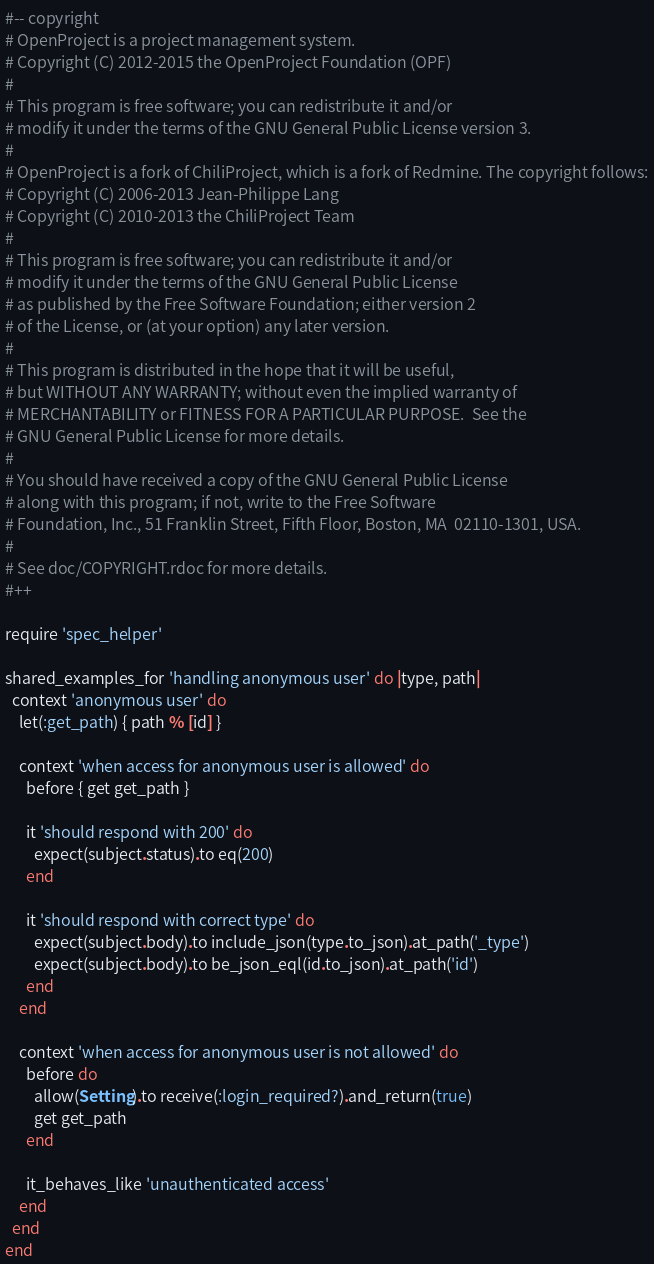<code> <loc_0><loc_0><loc_500><loc_500><_Ruby_>#-- copyright
# OpenProject is a project management system.
# Copyright (C) 2012-2015 the OpenProject Foundation (OPF)
#
# This program is free software; you can redistribute it and/or
# modify it under the terms of the GNU General Public License version 3.
#
# OpenProject is a fork of ChiliProject, which is a fork of Redmine. The copyright follows:
# Copyright (C) 2006-2013 Jean-Philippe Lang
# Copyright (C) 2010-2013 the ChiliProject Team
#
# This program is free software; you can redistribute it and/or
# modify it under the terms of the GNU General Public License
# as published by the Free Software Foundation; either version 2
# of the License, or (at your option) any later version.
#
# This program is distributed in the hope that it will be useful,
# but WITHOUT ANY WARRANTY; without even the implied warranty of
# MERCHANTABILITY or FITNESS FOR A PARTICULAR PURPOSE.  See the
# GNU General Public License for more details.
#
# You should have received a copy of the GNU General Public License
# along with this program; if not, write to the Free Software
# Foundation, Inc., 51 Franklin Street, Fifth Floor, Boston, MA  02110-1301, USA.
#
# See doc/COPYRIGHT.rdoc for more details.
#++

require 'spec_helper'

shared_examples_for 'handling anonymous user' do |type, path|
  context 'anonymous user' do
    let(:get_path) { path % [id] }

    context 'when access for anonymous user is allowed' do
      before { get get_path }

      it 'should respond with 200' do
        expect(subject.status).to eq(200)
      end

      it 'should respond with correct type' do
        expect(subject.body).to include_json(type.to_json).at_path('_type')
        expect(subject.body).to be_json_eql(id.to_json).at_path('id')
      end
    end

    context 'when access for anonymous user is not allowed' do
      before do
        allow(Setting).to receive(:login_required?).and_return(true)
        get get_path
      end

      it_behaves_like 'unauthenticated access'
    end
  end
end
</code> 